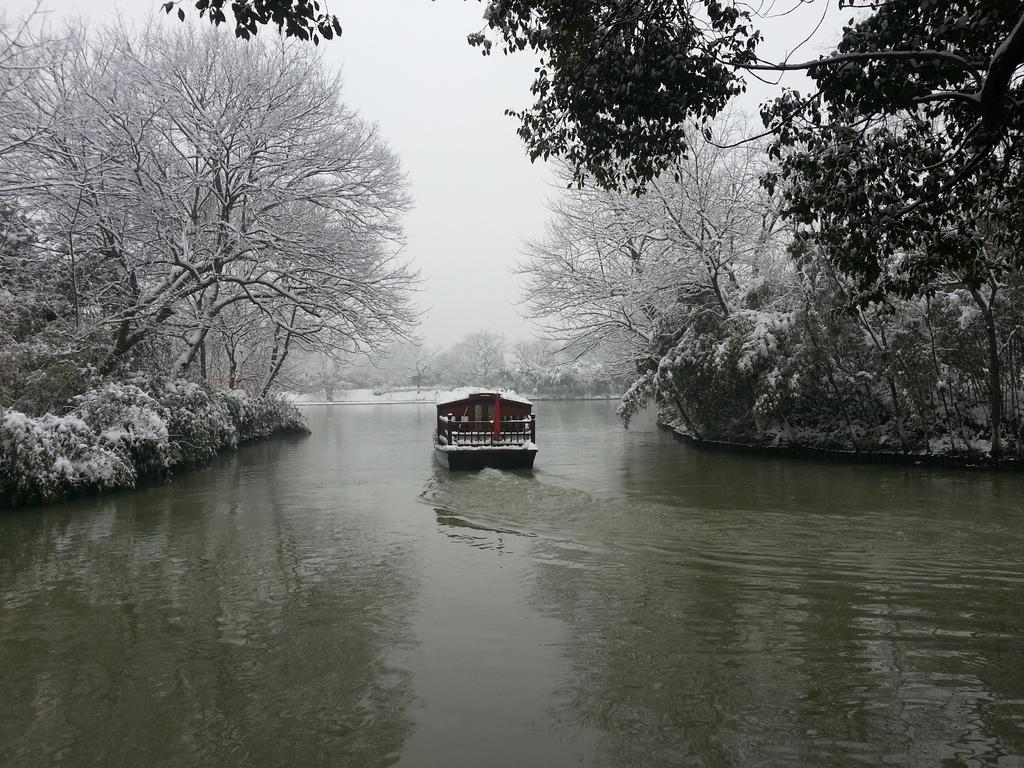What type of vegetation can be seen in the image? There are trees in the image. What is the main object in the water? There is a boat in the water. What is the surface on which the trees and boat are situated? There is water visible in the image. What is the weather like in the image? The presence of snow in the image suggests a cold or wintry environment. What is the color of the sky in the image? The sky is white in color. What type of parcel is being delivered by the queen in the image? There is no queen or parcel present in the image. How does the queen rule over the snowy landscape in the image? There is no queen or indication of a ruler in the image; it simply depicts a snowy landscape with trees, a boat, and water. 